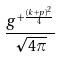Convert formula to latex. <formula><loc_0><loc_0><loc_500><loc_500>\frac { g ^ { + \frac { ( k + p ) ^ { 2 } } { 4 } } } { \sqrt { 4 \pi } }</formula> 